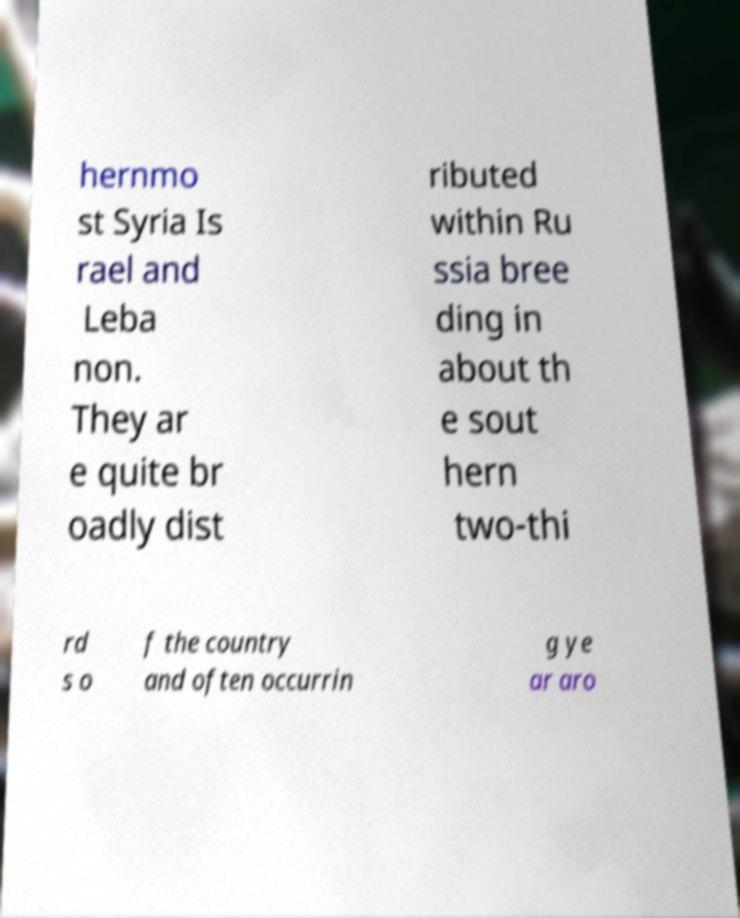Please read and relay the text visible in this image. What does it say? hernmo st Syria Is rael and Leba non. They ar e quite br oadly dist ributed within Ru ssia bree ding in about th e sout hern two-thi rd s o f the country and often occurrin g ye ar aro 